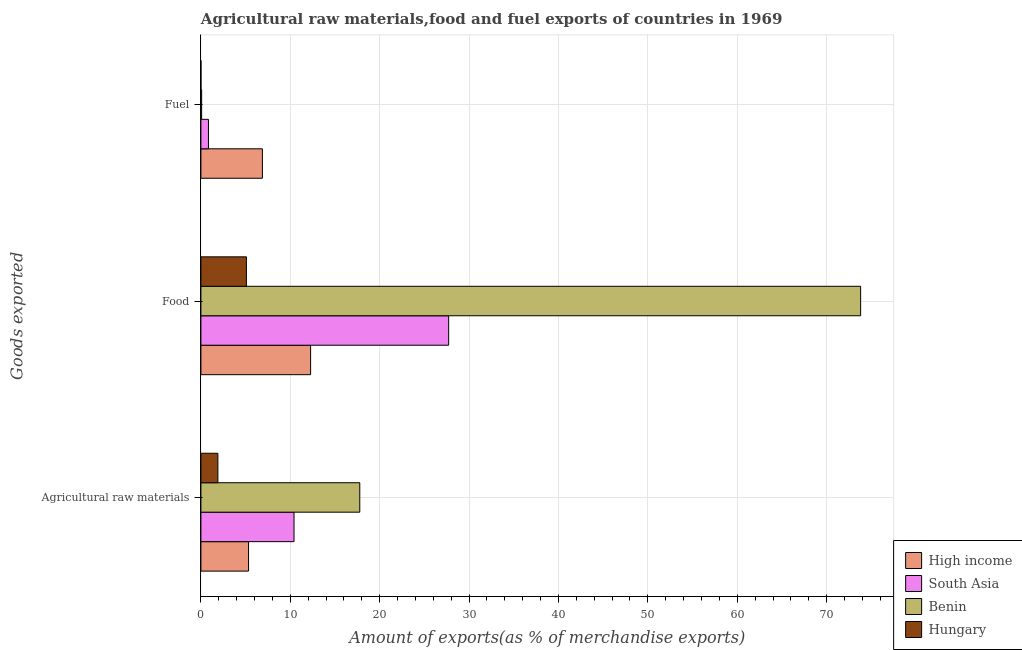How many different coloured bars are there?
Offer a very short reply. 4. How many groups of bars are there?
Make the answer very short. 3. How many bars are there on the 1st tick from the bottom?
Ensure brevity in your answer.  4. What is the label of the 1st group of bars from the top?
Provide a succinct answer. Fuel. What is the percentage of fuel exports in South Asia?
Ensure brevity in your answer.  0.84. Across all countries, what is the maximum percentage of fuel exports?
Your answer should be very brief. 6.88. Across all countries, what is the minimum percentage of food exports?
Make the answer very short. 5.09. In which country was the percentage of fuel exports maximum?
Provide a short and direct response. High income. In which country was the percentage of raw materials exports minimum?
Your response must be concise. Hungary. What is the total percentage of raw materials exports in the graph?
Keep it short and to the point. 35.42. What is the difference between the percentage of food exports in South Asia and that in Hungary?
Provide a short and direct response. 22.63. What is the difference between the percentage of fuel exports in High income and the percentage of food exports in Hungary?
Your response must be concise. 1.79. What is the average percentage of food exports per country?
Offer a very short reply. 29.72. What is the difference between the percentage of food exports and percentage of fuel exports in South Asia?
Your response must be concise. 26.87. What is the ratio of the percentage of food exports in Hungary to that in High income?
Make the answer very short. 0.41. Is the percentage of food exports in High income less than that in Benin?
Your answer should be compact. Yes. Is the difference between the percentage of raw materials exports in Hungary and High income greater than the difference between the percentage of fuel exports in Hungary and High income?
Keep it short and to the point. Yes. What is the difference between the highest and the second highest percentage of raw materials exports?
Provide a succinct answer. 7.36. What is the difference between the highest and the lowest percentage of raw materials exports?
Make the answer very short. 15.88. What does the 1st bar from the top in Food represents?
Give a very brief answer. Hungary. What does the 1st bar from the bottom in Fuel represents?
Ensure brevity in your answer.  High income. Is it the case that in every country, the sum of the percentage of raw materials exports and percentage of food exports is greater than the percentage of fuel exports?
Make the answer very short. Yes. How many bars are there?
Provide a short and direct response. 12. What is the difference between two consecutive major ticks on the X-axis?
Your response must be concise. 10. Does the graph contain any zero values?
Offer a very short reply. No. Where does the legend appear in the graph?
Offer a very short reply. Bottom right. How are the legend labels stacked?
Your answer should be very brief. Vertical. What is the title of the graph?
Offer a very short reply. Agricultural raw materials,food and fuel exports of countries in 1969. What is the label or title of the X-axis?
Ensure brevity in your answer.  Amount of exports(as % of merchandise exports). What is the label or title of the Y-axis?
Ensure brevity in your answer.  Goods exported. What is the Amount of exports(as % of merchandise exports) of High income in Agricultural raw materials?
Offer a very short reply. 5.33. What is the Amount of exports(as % of merchandise exports) in South Asia in Agricultural raw materials?
Keep it short and to the point. 10.42. What is the Amount of exports(as % of merchandise exports) in Benin in Agricultural raw materials?
Your response must be concise. 17.77. What is the Amount of exports(as % of merchandise exports) in Hungary in Agricultural raw materials?
Provide a succinct answer. 1.9. What is the Amount of exports(as % of merchandise exports) of High income in Food?
Your answer should be very brief. 12.27. What is the Amount of exports(as % of merchandise exports) of South Asia in Food?
Provide a succinct answer. 27.71. What is the Amount of exports(as % of merchandise exports) of Benin in Food?
Keep it short and to the point. 73.8. What is the Amount of exports(as % of merchandise exports) of Hungary in Food?
Keep it short and to the point. 5.09. What is the Amount of exports(as % of merchandise exports) in High income in Fuel?
Provide a succinct answer. 6.88. What is the Amount of exports(as % of merchandise exports) of South Asia in Fuel?
Give a very brief answer. 0.84. What is the Amount of exports(as % of merchandise exports) of Benin in Fuel?
Keep it short and to the point. 0.08. What is the Amount of exports(as % of merchandise exports) in Hungary in Fuel?
Keep it short and to the point. 0. Across all Goods exported, what is the maximum Amount of exports(as % of merchandise exports) of High income?
Give a very brief answer. 12.27. Across all Goods exported, what is the maximum Amount of exports(as % of merchandise exports) of South Asia?
Offer a terse response. 27.71. Across all Goods exported, what is the maximum Amount of exports(as % of merchandise exports) of Benin?
Your response must be concise. 73.8. Across all Goods exported, what is the maximum Amount of exports(as % of merchandise exports) of Hungary?
Keep it short and to the point. 5.09. Across all Goods exported, what is the minimum Amount of exports(as % of merchandise exports) of High income?
Your answer should be very brief. 5.33. Across all Goods exported, what is the minimum Amount of exports(as % of merchandise exports) of South Asia?
Your answer should be compact. 0.84. Across all Goods exported, what is the minimum Amount of exports(as % of merchandise exports) of Benin?
Provide a succinct answer. 0.08. Across all Goods exported, what is the minimum Amount of exports(as % of merchandise exports) of Hungary?
Your response must be concise. 0. What is the total Amount of exports(as % of merchandise exports) in High income in the graph?
Keep it short and to the point. 24.48. What is the total Amount of exports(as % of merchandise exports) of South Asia in the graph?
Give a very brief answer. 38.97. What is the total Amount of exports(as % of merchandise exports) in Benin in the graph?
Offer a very short reply. 91.66. What is the total Amount of exports(as % of merchandise exports) of Hungary in the graph?
Your answer should be very brief. 6.99. What is the difference between the Amount of exports(as % of merchandise exports) in High income in Agricultural raw materials and that in Food?
Keep it short and to the point. -6.94. What is the difference between the Amount of exports(as % of merchandise exports) in South Asia in Agricultural raw materials and that in Food?
Your response must be concise. -17.3. What is the difference between the Amount of exports(as % of merchandise exports) of Benin in Agricultural raw materials and that in Food?
Your answer should be compact. -56.03. What is the difference between the Amount of exports(as % of merchandise exports) in Hungary in Agricultural raw materials and that in Food?
Provide a short and direct response. -3.19. What is the difference between the Amount of exports(as % of merchandise exports) of High income in Agricultural raw materials and that in Fuel?
Keep it short and to the point. -1.55. What is the difference between the Amount of exports(as % of merchandise exports) in South Asia in Agricultural raw materials and that in Fuel?
Your response must be concise. 9.57. What is the difference between the Amount of exports(as % of merchandise exports) of Benin in Agricultural raw materials and that in Fuel?
Your answer should be compact. 17.69. What is the difference between the Amount of exports(as % of merchandise exports) in Hungary in Agricultural raw materials and that in Fuel?
Your response must be concise. 1.9. What is the difference between the Amount of exports(as % of merchandise exports) of High income in Food and that in Fuel?
Give a very brief answer. 5.39. What is the difference between the Amount of exports(as % of merchandise exports) in South Asia in Food and that in Fuel?
Provide a succinct answer. 26.87. What is the difference between the Amount of exports(as % of merchandise exports) in Benin in Food and that in Fuel?
Your answer should be compact. 73.72. What is the difference between the Amount of exports(as % of merchandise exports) in Hungary in Food and that in Fuel?
Your answer should be very brief. 5.09. What is the difference between the Amount of exports(as % of merchandise exports) in High income in Agricultural raw materials and the Amount of exports(as % of merchandise exports) in South Asia in Food?
Provide a succinct answer. -22.38. What is the difference between the Amount of exports(as % of merchandise exports) in High income in Agricultural raw materials and the Amount of exports(as % of merchandise exports) in Benin in Food?
Your answer should be compact. -68.47. What is the difference between the Amount of exports(as % of merchandise exports) in High income in Agricultural raw materials and the Amount of exports(as % of merchandise exports) in Hungary in Food?
Provide a short and direct response. 0.24. What is the difference between the Amount of exports(as % of merchandise exports) in South Asia in Agricultural raw materials and the Amount of exports(as % of merchandise exports) in Benin in Food?
Offer a very short reply. -63.39. What is the difference between the Amount of exports(as % of merchandise exports) in South Asia in Agricultural raw materials and the Amount of exports(as % of merchandise exports) in Hungary in Food?
Provide a short and direct response. 5.33. What is the difference between the Amount of exports(as % of merchandise exports) in Benin in Agricultural raw materials and the Amount of exports(as % of merchandise exports) in Hungary in Food?
Your response must be concise. 12.68. What is the difference between the Amount of exports(as % of merchandise exports) of High income in Agricultural raw materials and the Amount of exports(as % of merchandise exports) of South Asia in Fuel?
Offer a terse response. 4.49. What is the difference between the Amount of exports(as % of merchandise exports) of High income in Agricultural raw materials and the Amount of exports(as % of merchandise exports) of Benin in Fuel?
Provide a succinct answer. 5.25. What is the difference between the Amount of exports(as % of merchandise exports) in High income in Agricultural raw materials and the Amount of exports(as % of merchandise exports) in Hungary in Fuel?
Offer a very short reply. 5.33. What is the difference between the Amount of exports(as % of merchandise exports) in South Asia in Agricultural raw materials and the Amount of exports(as % of merchandise exports) in Benin in Fuel?
Keep it short and to the point. 10.34. What is the difference between the Amount of exports(as % of merchandise exports) in South Asia in Agricultural raw materials and the Amount of exports(as % of merchandise exports) in Hungary in Fuel?
Your answer should be compact. 10.42. What is the difference between the Amount of exports(as % of merchandise exports) in Benin in Agricultural raw materials and the Amount of exports(as % of merchandise exports) in Hungary in Fuel?
Offer a terse response. 17.77. What is the difference between the Amount of exports(as % of merchandise exports) in High income in Food and the Amount of exports(as % of merchandise exports) in South Asia in Fuel?
Make the answer very short. 11.43. What is the difference between the Amount of exports(as % of merchandise exports) in High income in Food and the Amount of exports(as % of merchandise exports) in Benin in Fuel?
Your answer should be compact. 12.19. What is the difference between the Amount of exports(as % of merchandise exports) of High income in Food and the Amount of exports(as % of merchandise exports) of Hungary in Fuel?
Keep it short and to the point. 12.27. What is the difference between the Amount of exports(as % of merchandise exports) of South Asia in Food and the Amount of exports(as % of merchandise exports) of Benin in Fuel?
Provide a short and direct response. 27.63. What is the difference between the Amount of exports(as % of merchandise exports) in South Asia in Food and the Amount of exports(as % of merchandise exports) in Hungary in Fuel?
Your response must be concise. 27.71. What is the difference between the Amount of exports(as % of merchandise exports) of Benin in Food and the Amount of exports(as % of merchandise exports) of Hungary in Fuel?
Your answer should be very brief. 73.8. What is the average Amount of exports(as % of merchandise exports) of High income per Goods exported?
Your answer should be very brief. 8.16. What is the average Amount of exports(as % of merchandise exports) in South Asia per Goods exported?
Ensure brevity in your answer.  12.99. What is the average Amount of exports(as % of merchandise exports) of Benin per Goods exported?
Provide a succinct answer. 30.55. What is the average Amount of exports(as % of merchandise exports) in Hungary per Goods exported?
Offer a very short reply. 2.33. What is the difference between the Amount of exports(as % of merchandise exports) in High income and Amount of exports(as % of merchandise exports) in South Asia in Agricultural raw materials?
Ensure brevity in your answer.  -5.09. What is the difference between the Amount of exports(as % of merchandise exports) in High income and Amount of exports(as % of merchandise exports) in Benin in Agricultural raw materials?
Keep it short and to the point. -12.44. What is the difference between the Amount of exports(as % of merchandise exports) of High income and Amount of exports(as % of merchandise exports) of Hungary in Agricultural raw materials?
Your response must be concise. 3.43. What is the difference between the Amount of exports(as % of merchandise exports) of South Asia and Amount of exports(as % of merchandise exports) of Benin in Agricultural raw materials?
Give a very brief answer. -7.36. What is the difference between the Amount of exports(as % of merchandise exports) of South Asia and Amount of exports(as % of merchandise exports) of Hungary in Agricultural raw materials?
Give a very brief answer. 8.52. What is the difference between the Amount of exports(as % of merchandise exports) in Benin and Amount of exports(as % of merchandise exports) in Hungary in Agricultural raw materials?
Ensure brevity in your answer.  15.88. What is the difference between the Amount of exports(as % of merchandise exports) of High income and Amount of exports(as % of merchandise exports) of South Asia in Food?
Offer a very short reply. -15.44. What is the difference between the Amount of exports(as % of merchandise exports) in High income and Amount of exports(as % of merchandise exports) in Benin in Food?
Make the answer very short. -61.53. What is the difference between the Amount of exports(as % of merchandise exports) of High income and Amount of exports(as % of merchandise exports) of Hungary in Food?
Give a very brief answer. 7.18. What is the difference between the Amount of exports(as % of merchandise exports) of South Asia and Amount of exports(as % of merchandise exports) of Benin in Food?
Your answer should be compact. -46.09. What is the difference between the Amount of exports(as % of merchandise exports) of South Asia and Amount of exports(as % of merchandise exports) of Hungary in Food?
Make the answer very short. 22.63. What is the difference between the Amount of exports(as % of merchandise exports) in Benin and Amount of exports(as % of merchandise exports) in Hungary in Food?
Ensure brevity in your answer.  68.71. What is the difference between the Amount of exports(as % of merchandise exports) in High income and Amount of exports(as % of merchandise exports) in South Asia in Fuel?
Provide a short and direct response. 6.04. What is the difference between the Amount of exports(as % of merchandise exports) in High income and Amount of exports(as % of merchandise exports) in Benin in Fuel?
Offer a very short reply. 6.8. What is the difference between the Amount of exports(as % of merchandise exports) of High income and Amount of exports(as % of merchandise exports) of Hungary in Fuel?
Your answer should be compact. 6.88. What is the difference between the Amount of exports(as % of merchandise exports) in South Asia and Amount of exports(as % of merchandise exports) in Benin in Fuel?
Offer a very short reply. 0.76. What is the difference between the Amount of exports(as % of merchandise exports) of South Asia and Amount of exports(as % of merchandise exports) of Hungary in Fuel?
Provide a succinct answer. 0.84. What is the difference between the Amount of exports(as % of merchandise exports) in Benin and Amount of exports(as % of merchandise exports) in Hungary in Fuel?
Your answer should be compact. 0.08. What is the ratio of the Amount of exports(as % of merchandise exports) in High income in Agricultural raw materials to that in Food?
Keep it short and to the point. 0.43. What is the ratio of the Amount of exports(as % of merchandise exports) of South Asia in Agricultural raw materials to that in Food?
Offer a very short reply. 0.38. What is the ratio of the Amount of exports(as % of merchandise exports) of Benin in Agricultural raw materials to that in Food?
Ensure brevity in your answer.  0.24. What is the ratio of the Amount of exports(as % of merchandise exports) of Hungary in Agricultural raw materials to that in Food?
Provide a succinct answer. 0.37. What is the ratio of the Amount of exports(as % of merchandise exports) in High income in Agricultural raw materials to that in Fuel?
Make the answer very short. 0.77. What is the ratio of the Amount of exports(as % of merchandise exports) in South Asia in Agricultural raw materials to that in Fuel?
Your answer should be very brief. 12.36. What is the ratio of the Amount of exports(as % of merchandise exports) of Benin in Agricultural raw materials to that in Fuel?
Offer a very short reply. 218.42. What is the ratio of the Amount of exports(as % of merchandise exports) of Hungary in Agricultural raw materials to that in Fuel?
Provide a short and direct response. 1804.6. What is the ratio of the Amount of exports(as % of merchandise exports) in High income in Food to that in Fuel?
Keep it short and to the point. 1.78. What is the ratio of the Amount of exports(as % of merchandise exports) in South Asia in Food to that in Fuel?
Offer a very short reply. 32.88. What is the ratio of the Amount of exports(as % of merchandise exports) in Benin in Food to that in Fuel?
Your answer should be compact. 906.97. What is the ratio of the Amount of exports(as % of merchandise exports) in Hungary in Food to that in Fuel?
Your answer should be very brief. 4841.44. What is the difference between the highest and the second highest Amount of exports(as % of merchandise exports) of High income?
Give a very brief answer. 5.39. What is the difference between the highest and the second highest Amount of exports(as % of merchandise exports) in South Asia?
Your response must be concise. 17.3. What is the difference between the highest and the second highest Amount of exports(as % of merchandise exports) in Benin?
Provide a succinct answer. 56.03. What is the difference between the highest and the second highest Amount of exports(as % of merchandise exports) of Hungary?
Your response must be concise. 3.19. What is the difference between the highest and the lowest Amount of exports(as % of merchandise exports) of High income?
Ensure brevity in your answer.  6.94. What is the difference between the highest and the lowest Amount of exports(as % of merchandise exports) of South Asia?
Your answer should be very brief. 26.87. What is the difference between the highest and the lowest Amount of exports(as % of merchandise exports) in Benin?
Your answer should be compact. 73.72. What is the difference between the highest and the lowest Amount of exports(as % of merchandise exports) in Hungary?
Provide a short and direct response. 5.09. 